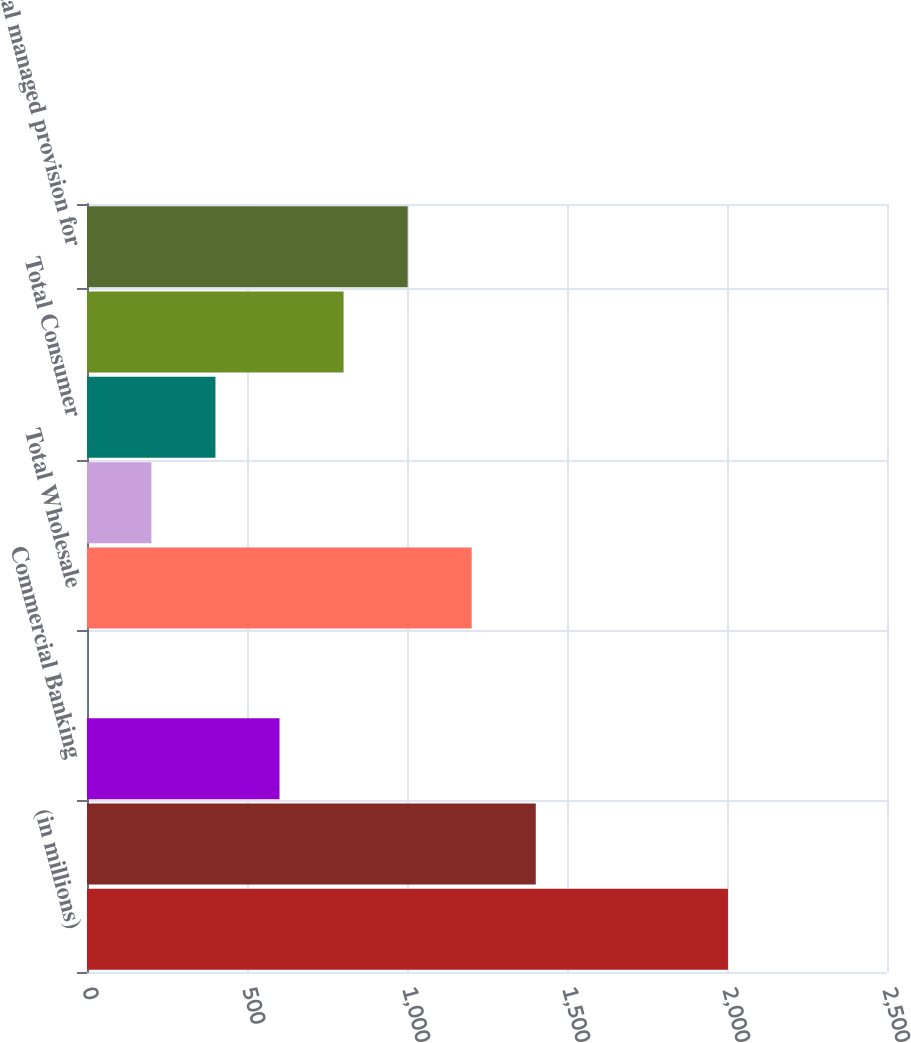Convert chart. <chart><loc_0><loc_0><loc_500><loc_500><bar_chart><fcel>(in millions)<fcel>Investment Bank<fcel>Commercial Banking<fcel>Asset & Wealth Management<fcel>Total Wholesale<fcel>Retail Financial Services<fcel>Total Consumer<fcel>Total provision for credit<fcel>Total managed provision for<nl><fcel>2003<fcel>1402.4<fcel>601.6<fcel>1<fcel>1202.2<fcel>201.2<fcel>401.4<fcel>801.8<fcel>1002<nl></chart> 